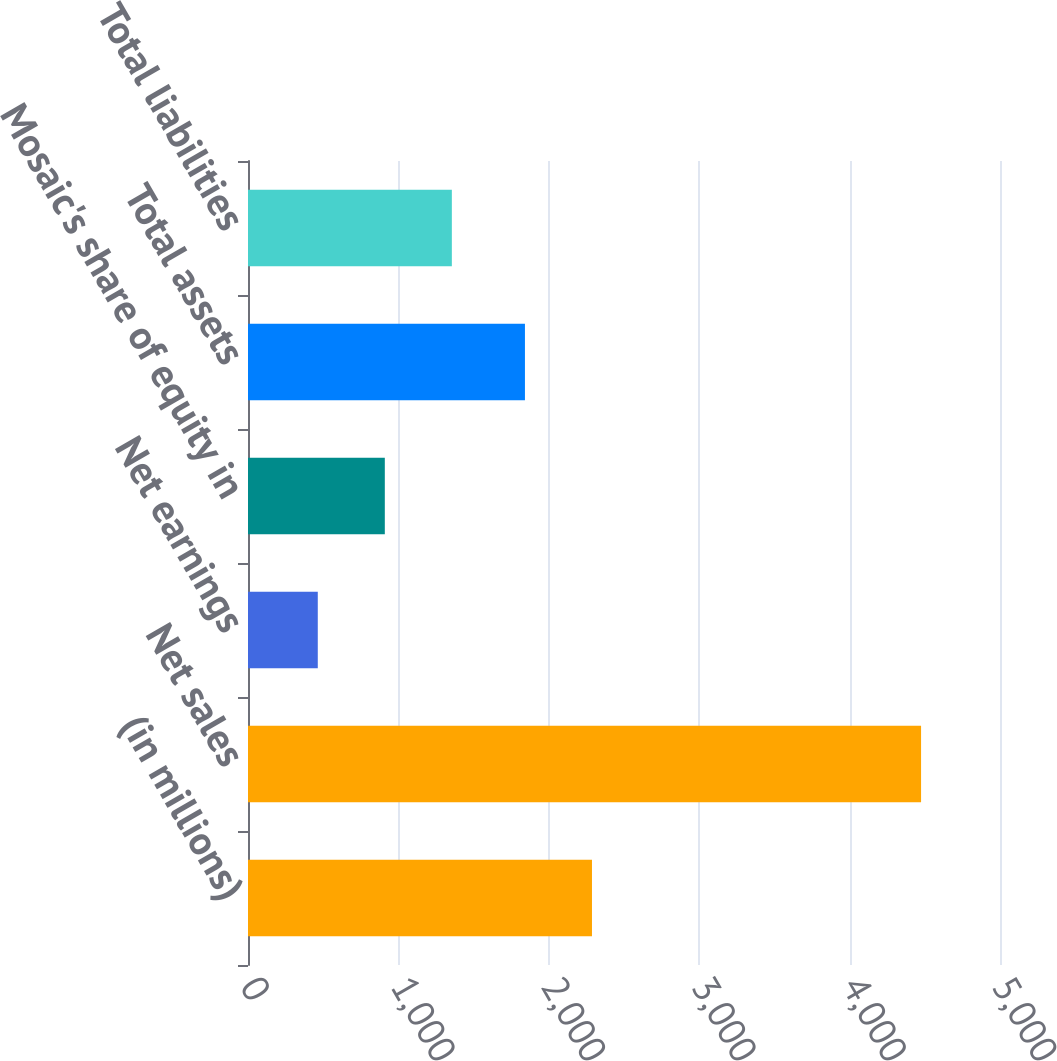Convert chart to OTSL. <chart><loc_0><loc_0><loc_500><loc_500><bar_chart><fcel>(in millions)<fcel>Net sales<fcel>Net earnings<fcel>Mosaic's share of equity in<fcel>Total assets<fcel>Total liabilities<nl><fcel>2287.09<fcel>4475.2<fcel>463.99<fcel>909.68<fcel>1841.4<fcel>1355.37<nl></chart> 